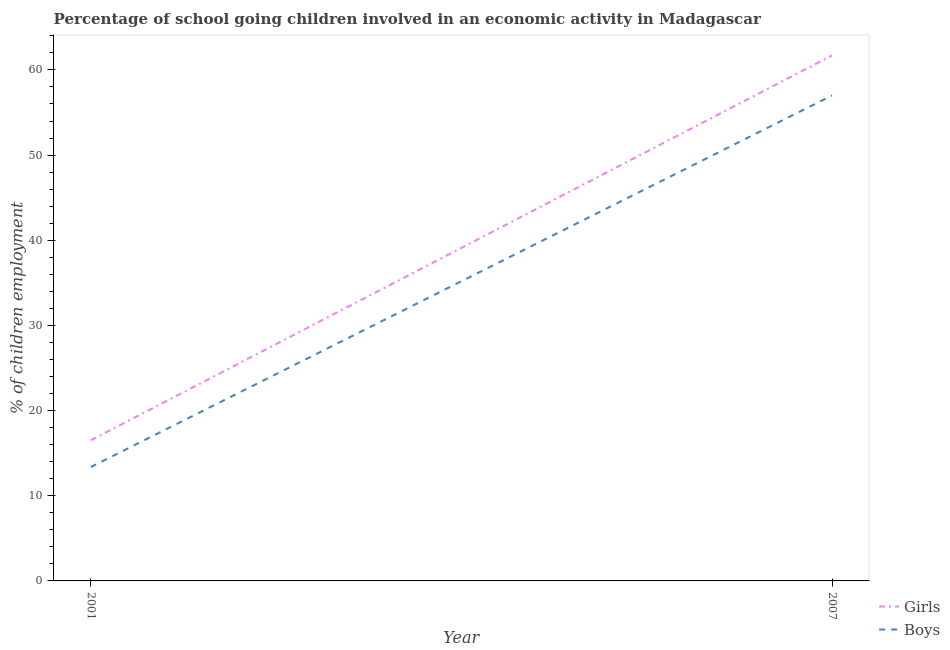What is the percentage of school going boys in 2007?
Your response must be concise. 57. Across all years, what is the maximum percentage of school going boys?
Give a very brief answer. 57. Across all years, what is the minimum percentage of school going boys?
Provide a succinct answer. 13.37. What is the total percentage of school going girls in the graph?
Your answer should be very brief. 78.21. What is the difference between the percentage of school going boys in 2001 and that in 2007?
Ensure brevity in your answer.  -43.63. What is the difference between the percentage of school going boys in 2001 and the percentage of school going girls in 2007?
Give a very brief answer. -48.33. What is the average percentage of school going boys per year?
Ensure brevity in your answer.  35.19. In the year 2007, what is the difference between the percentage of school going girls and percentage of school going boys?
Provide a short and direct response. 4.7. In how many years, is the percentage of school going girls greater than 50 %?
Offer a terse response. 1. What is the ratio of the percentage of school going girls in 2001 to that in 2007?
Offer a very short reply. 0.27. Is the percentage of school going boys strictly greater than the percentage of school going girls over the years?
Your answer should be very brief. No. Is the percentage of school going girls strictly less than the percentage of school going boys over the years?
Provide a short and direct response. No. How many lines are there?
Provide a short and direct response. 2. How many years are there in the graph?
Your response must be concise. 2. What is the difference between two consecutive major ticks on the Y-axis?
Ensure brevity in your answer.  10. Does the graph contain any zero values?
Give a very brief answer. No. Where does the legend appear in the graph?
Ensure brevity in your answer.  Bottom right. How many legend labels are there?
Offer a terse response. 2. What is the title of the graph?
Provide a succinct answer. Percentage of school going children involved in an economic activity in Madagascar. What is the label or title of the Y-axis?
Ensure brevity in your answer.  % of children employment. What is the % of children employment in Girls in 2001?
Give a very brief answer. 16.51. What is the % of children employment in Boys in 2001?
Provide a short and direct response. 13.37. What is the % of children employment in Girls in 2007?
Your answer should be compact. 61.7. Across all years, what is the maximum % of children employment in Girls?
Your answer should be very brief. 61.7. Across all years, what is the minimum % of children employment of Girls?
Keep it short and to the point. 16.51. Across all years, what is the minimum % of children employment of Boys?
Your answer should be very brief. 13.37. What is the total % of children employment in Girls in the graph?
Your answer should be very brief. 78.21. What is the total % of children employment in Boys in the graph?
Your response must be concise. 70.37. What is the difference between the % of children employment of Girls in 2001 and that in 2007?
Your answer should be compact. -45.19. What is the difference between the % of children employment of Boys in 2001 and that in 2007?
Provide a succinct answer. -43.63. What is the difference between the % of children employment of Girls in 2001 and the % of children employment of Boys in 2007?
Offer a terse response. -40.49. What is the average % of children employment in Girls per year?
Your response must be concise. 39.1. What is the average % of children employment in Boys per year?
Your answer should be compact. 35.19. In the year 2001, what is the difference between the % of children employment in Girls and % of children employment in Boys?
Ensure brevity in your answer.  3.14. In the year 2007, what is the difference between the % of children employment of Girls and % of children employment of Boys?
Offer a very short reply. 4.7. What is the ratio of the % of children employment of Girls in 2001 to that in 2007?
Provide a succinct answer. 0.27. What is the ratio of the % of children employment of Boys in 2001 to that in 2007?
Offer a very short reply. 0.23. What is the difference between the highest and the second highest % of children employment in Girls?
Your answer should be compact. 45.19. What is the difference between the highest and the second highest % of children employment of Boys?
Offer a terse response. 43.63. What is the difference between the highest and the lowest % of children employment in Girls?
Provide a short and direct response. 45.19. What is the difference between the highest and the lowest % of children employment of Boys?
Your answer should be very brief. 43.63. 